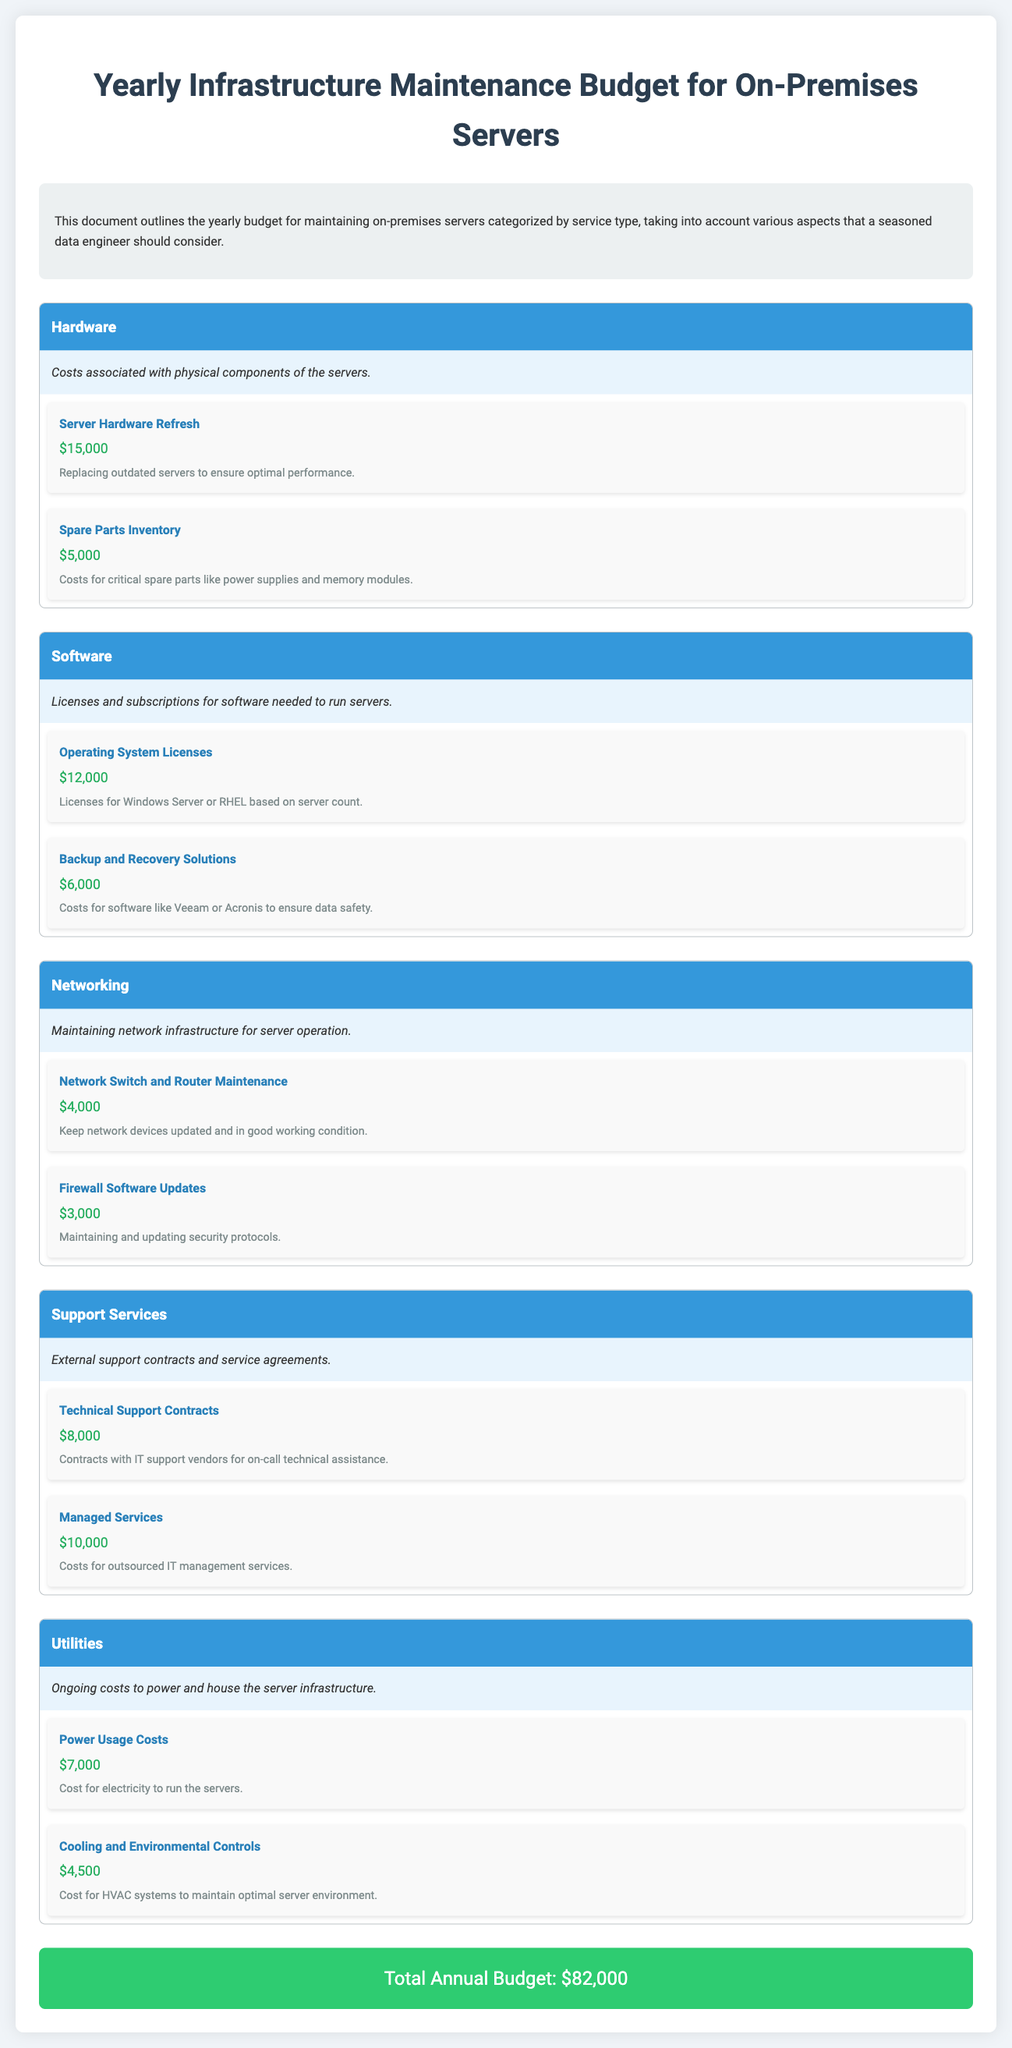What is the total annual budget? The total annual budget is explicitly stated at the end of the document.
Answer: $82,000 How much is allocated for Operating System Licenses? This specific item is found under the Software category, detailing its cost.
Answer: $12,000 What category does the item 'Server Hardware Refresh' belong to? The category is listed in the documentation, specifically mentioning hardware-related expenses.
Answer: Hardware How much is spent on Technical Support Contracts? This amount is specified under the Support Services category.
Answer: $8,000 What is the cost associated with Cooling and Environmental Controls? This cost is mentioned in the Utilities section, detailing what it covers.
Answer: $4,500 Which category has the highest individual cost item? This question requires looking across categories to identify the single highest cost listed.
Answer: Hardware (Server Hardware Refresh, $15,000) What type of services does the category 'Support Services' include? This category is defined by specific types of external services being discussed.
Answer: Technical Support Contracts and Managed Services What is the total cost of Networking items? This requires summing the costs from all items included in the Networking category as specified in the document.
Answer: $7,000 What description is provided for the Utilities category? The document includes a brief description for each category, explaining its overall purpose.
Answer: Ongoing costs to power and house the server infrastructure How many items are listed under the Software category? This is about counting the specific entries mentioned within a defined category.
Answer: 2 